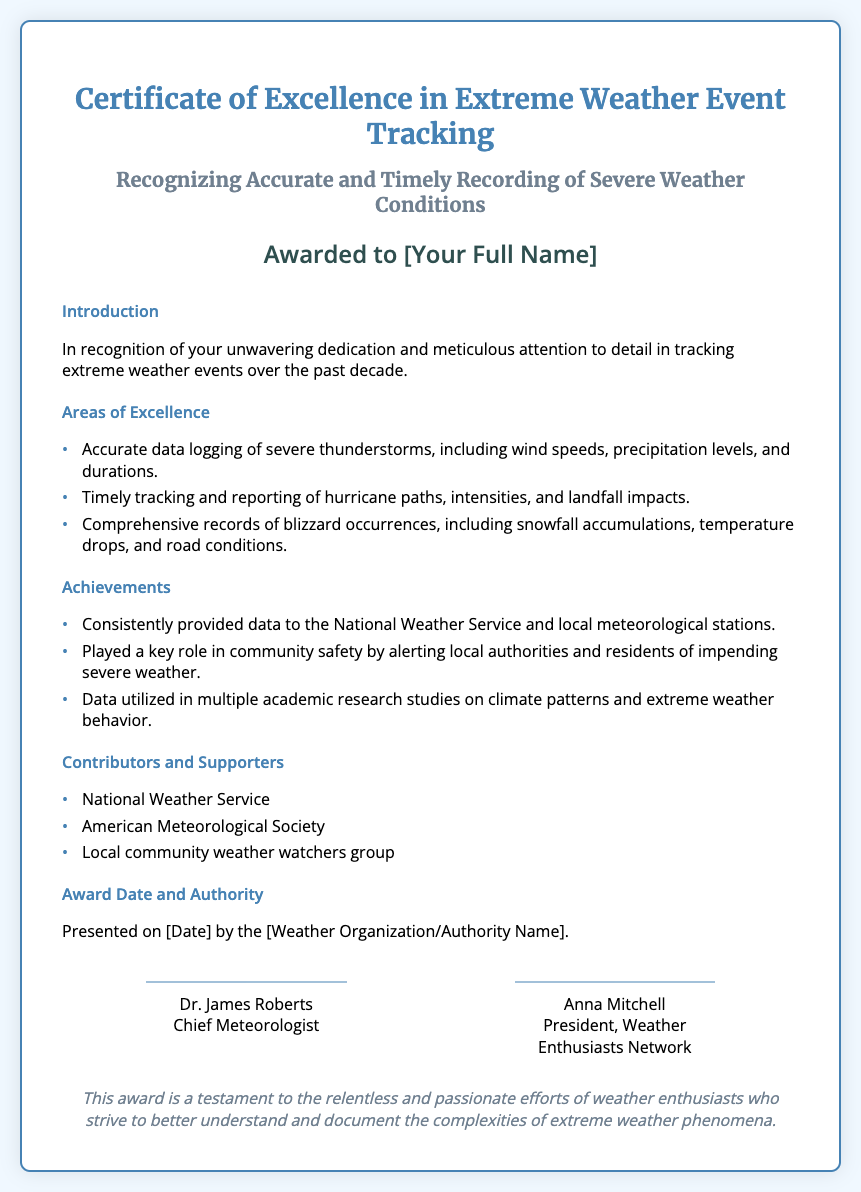What is the title of the certificate? The title of the certificate is explicitly stated at the top of the document.
Answer: Certificate of Excellence in Extreme Weather Event Tracking Who is the recipient of the certificate? The recipient's name is indicated in the designated area within the certificate.
Answer: [Your Full Name] Which areas of excellence are recognized in the certificate? The document lists specific areas of excellence under a section heading.
Answer: Accurate data logging, timely tracking, comprehensive records What achievements are mentioned in the certificate? The document highlights certain achievements in a separate section.
Answer: Provided data, community safety, academic studies Who presented the award? The authority that presented the award is specified in the document.
Answer: [Weather Organization/Authority Name] What is one of the contributors mentioned? The document lists contributors under a specific section.
Answer: National Weather Service Who are the two signatories of the certificate? The signature section contains the names of the individuals who signed the certificate.
Answer: Dr. James Roberts, Anna Mitchell What color is the border of the certificate? The visualization of the certificate indicates the color used for the border.
Answer: #4682b4 When was the award presented? Presentation date is mentioned in the document and is placed in a specific section.
Answer: [Date] 